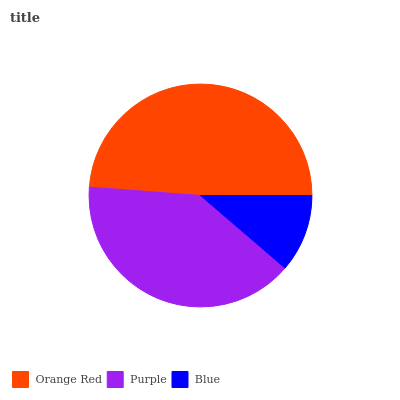Is Blue the minimum?
Answer yes or no. Yes. Is Orange Red the maximum?
Answer yes or no. Yes. Is Purple the minimum?
Answer yes or no. No. Is Purple the maximum?
Answer yes or no. No. Is Orange Red greater than Purple?
Answer yes or no. Yes. Is Purple less than Orange Red?
Answer yes or no. Yes. Is Purple greater than Orange Red?
Answer yes or no. No. Is Orange Red less than Purple?
Answer yes or no. No. Is Purple the high median?
Answer yes or no. Yes. Is Purple the low median?
Answer yes or no. Yes. Is Blue the high median?
Answer yes or no. No. Is Orange Red the low median?
Answer yes or no. No. 